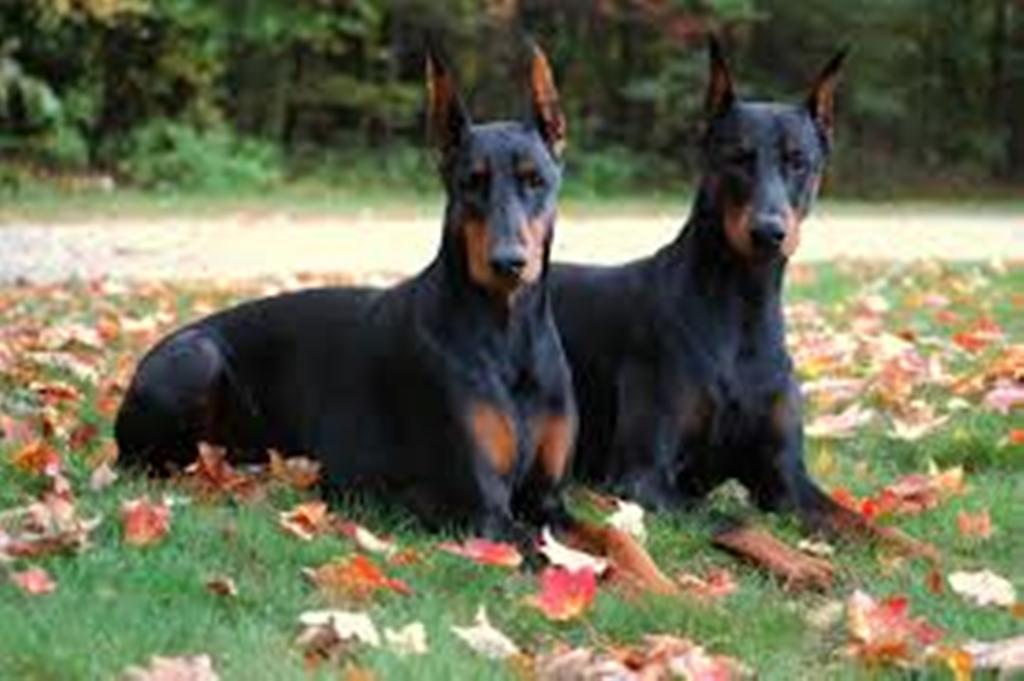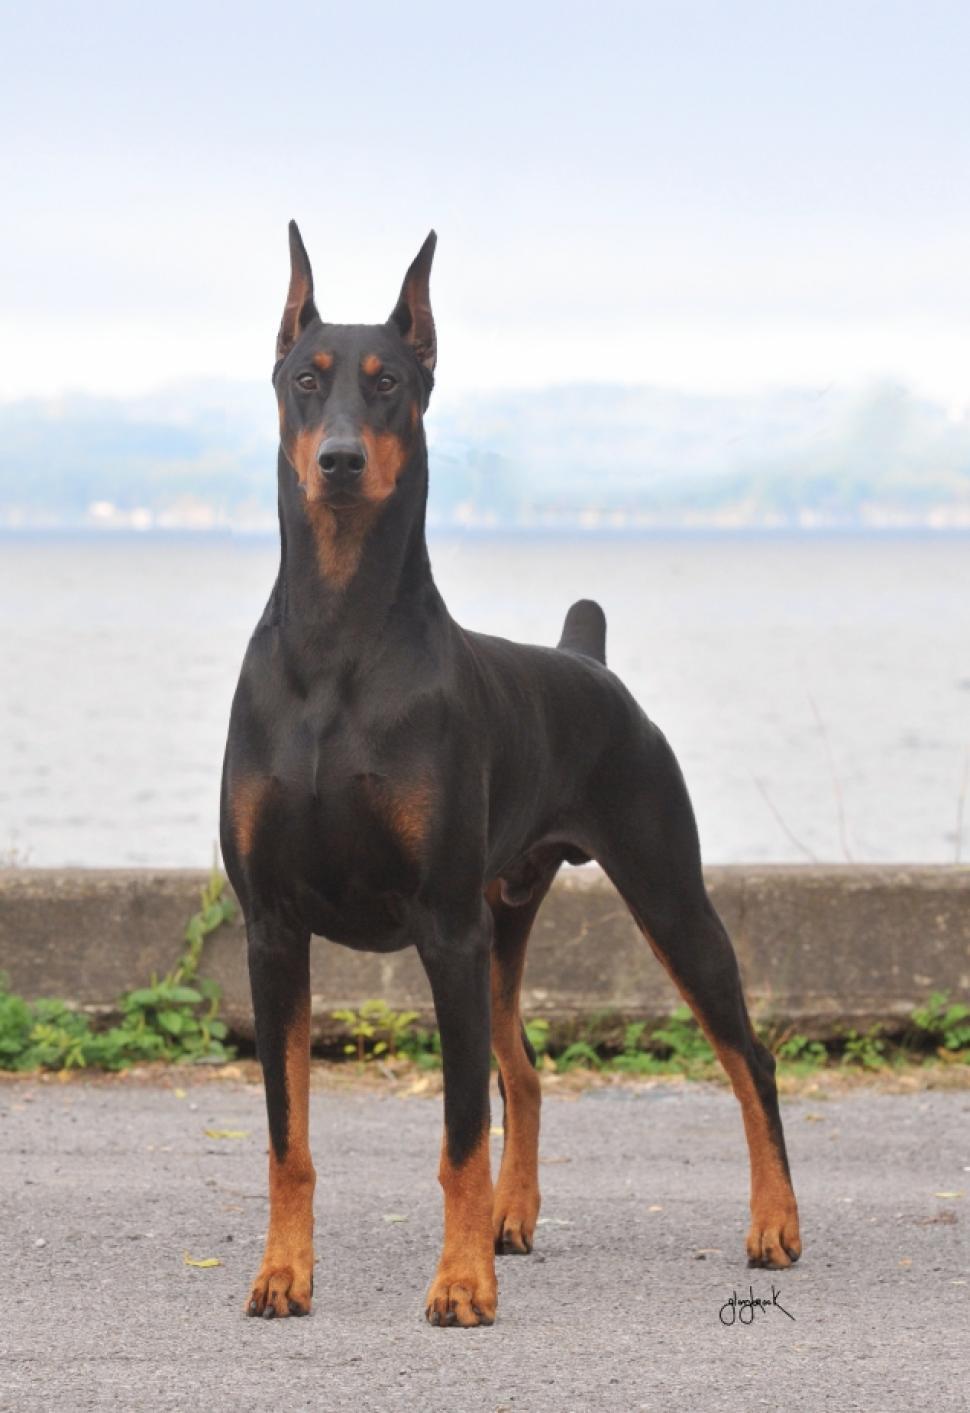The first image is the image on the left, the second image is the image on the right. Assess this claim about the two images: "Each image shows one dog standing in profile, and the left image shows a brown dog, while the right image shows a right-facing doberman with pointy ears and docked tail.". Correct or not? Answer yes or no. No. 